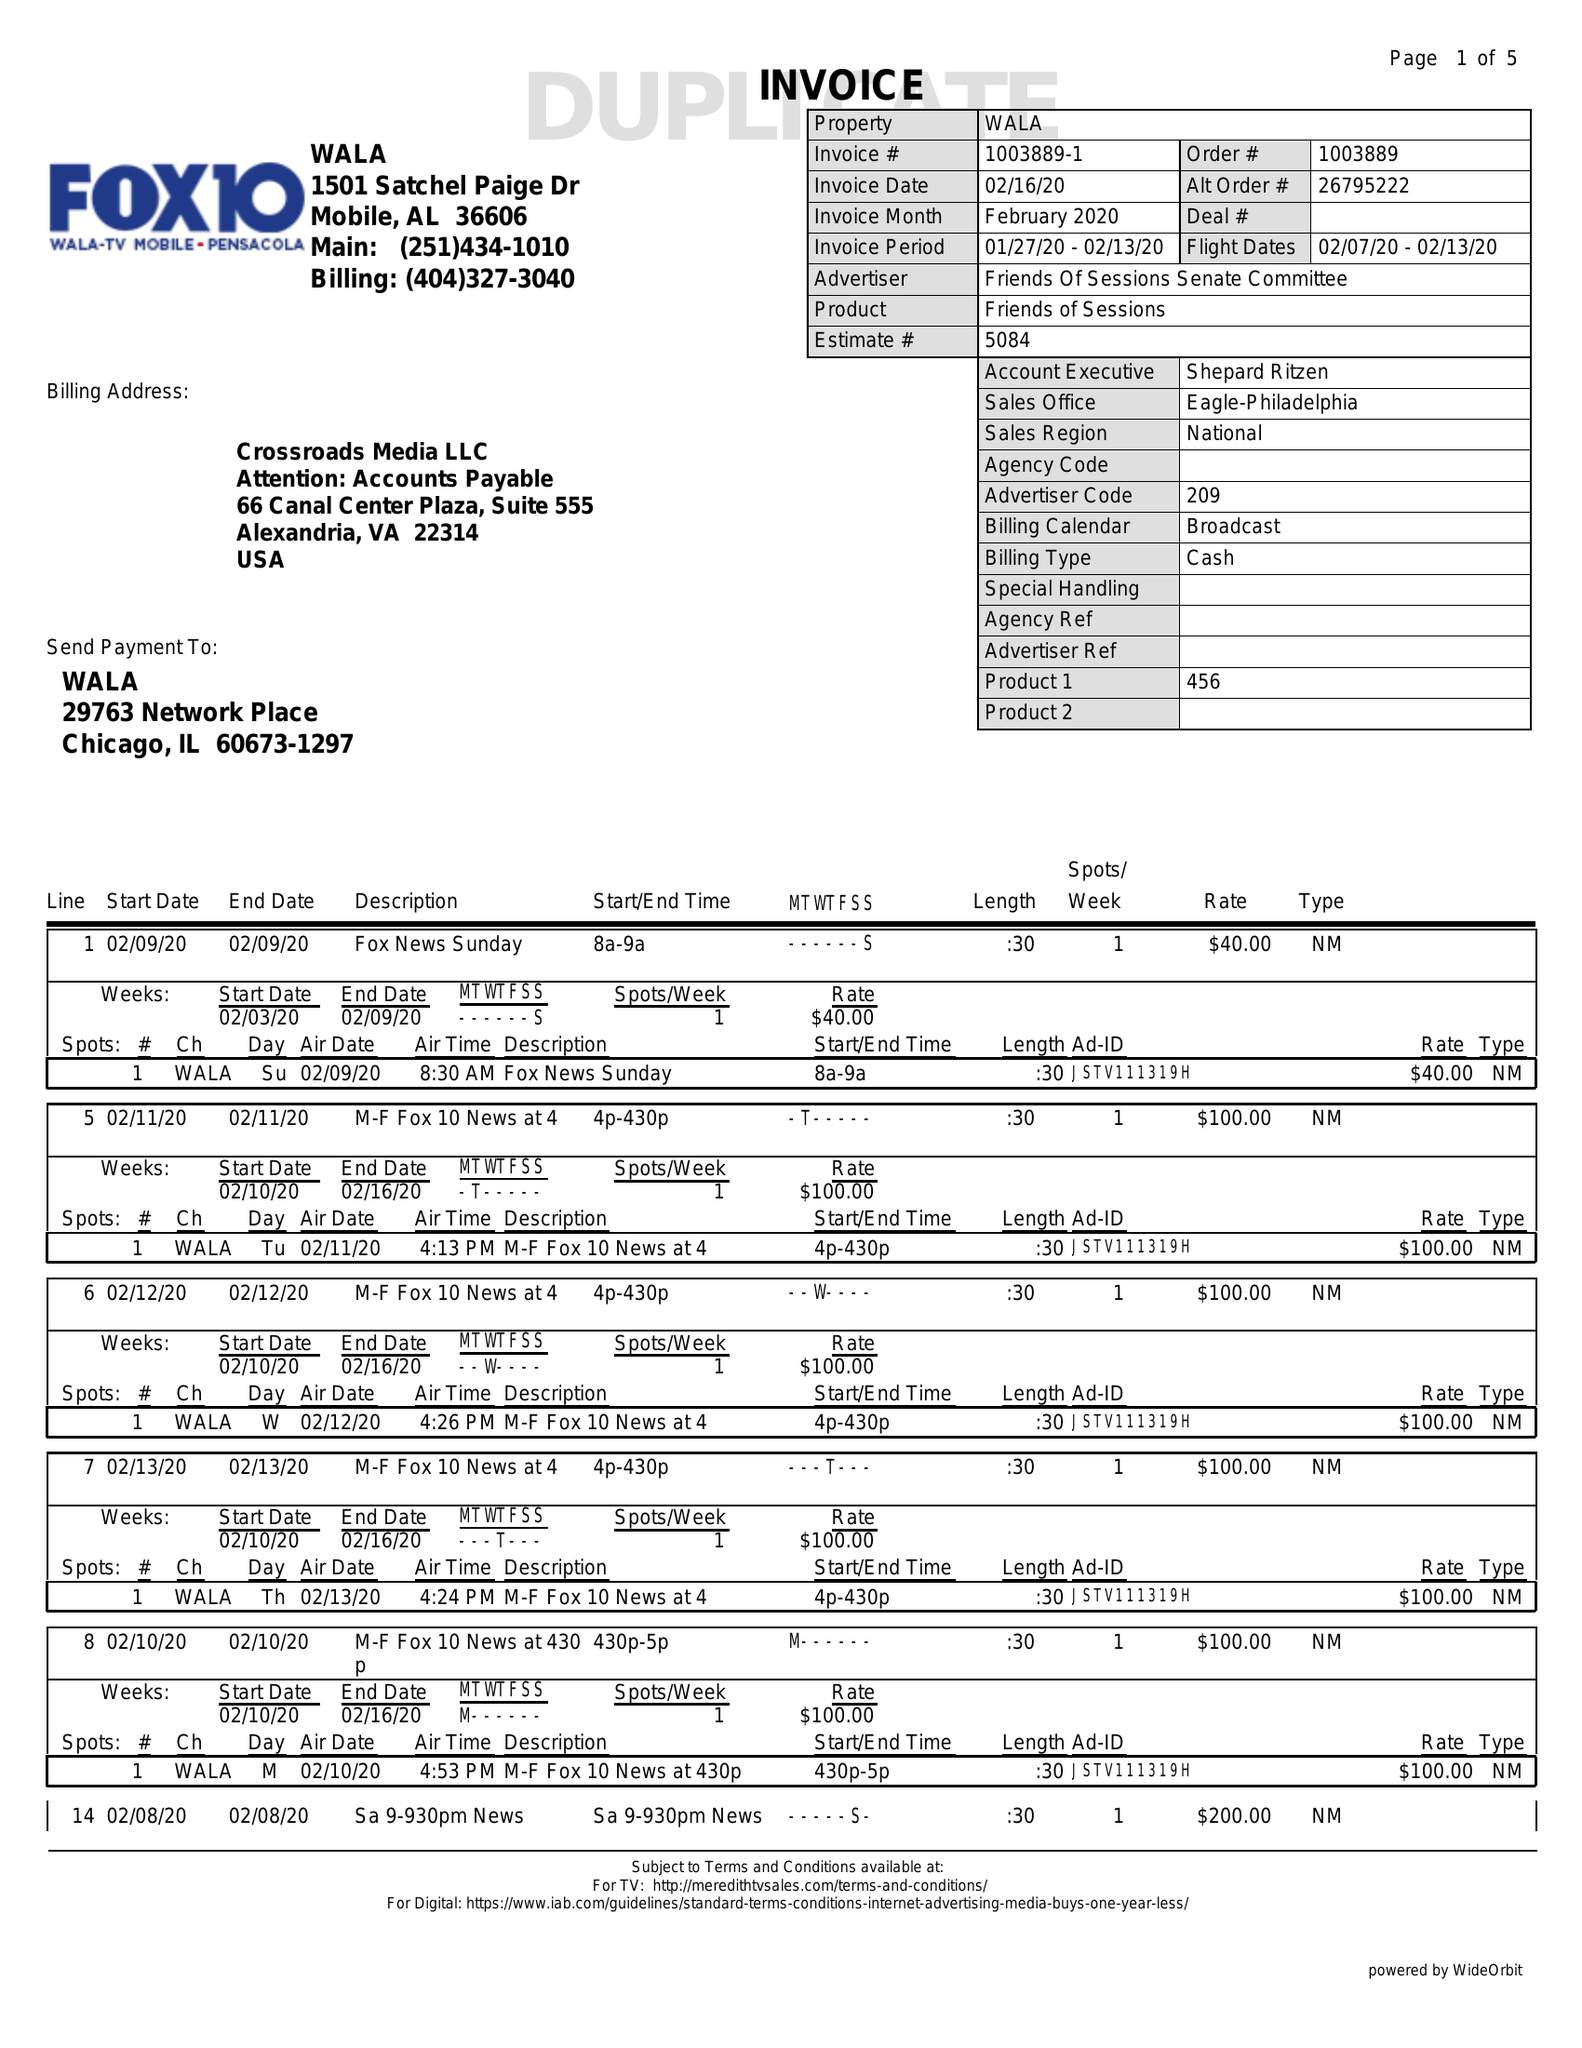What is the value for the gross_amount?
Answer the question using a single word or phrase. 15300.00 